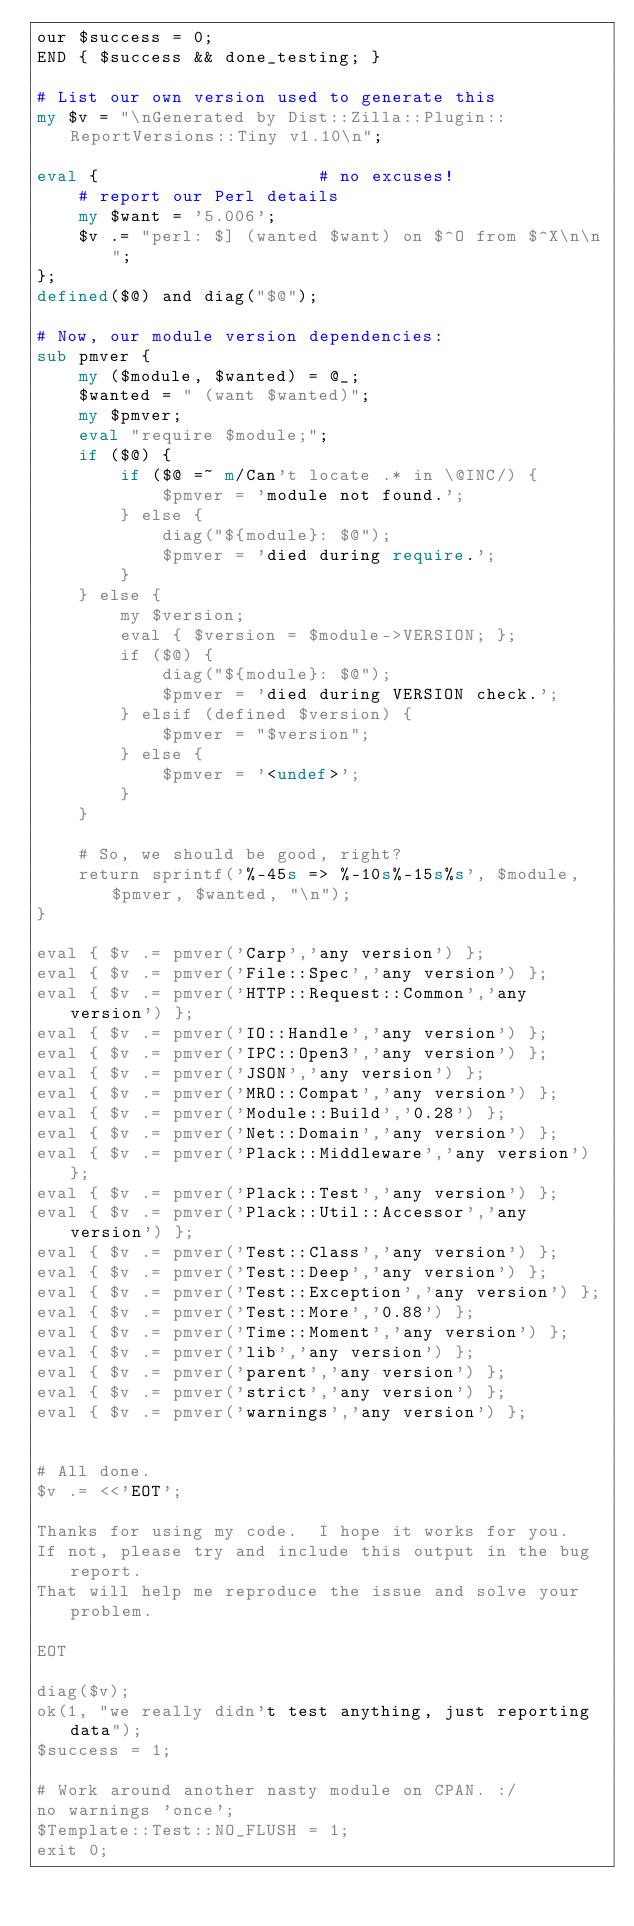Convert code to text. <code><loc_0><loc_0><loc_500><loc_500><_Perl_>our $success = 0;
END { $success && done_testing; }

# List our own version used to generate this
my $v = "\nGenerated by Dist::Zilla::Plugin::ReportVersions::Tiny v1.10\n";

eval {                     # no excuses!
    # report our Perl details
    my $want = '5.006';
    $v .= "perl: $] (wanted $want) on $^O from $^X\n\n";
};
defined($@) and diag("$@");

# Now, our module version dependencies:
sub pmver {
    my ($module, $wanted) = @_;
    $wanted = " (want $wanted)";
    my $pmver;
    eval "require $module;";
    if ($@) {
        if ($@ =~ m/Can't locate .* in \@INC/) {
            $pmver = 'module not found.';
        } else {
            diag("${module}: $@");
            $pmver = 'died during require.';
        }
    } else {
        my $version;
        eval { $version = $module->VERSION; };
        if ($@) {
            diag("${module}: $@");
            $pmver = 'died during VERSION check.';
        } elsif (defined $version) {
            $pmver = "$version";
        } else {
            $pmver = '<undef>';
        }
    }

    # So, we should be good, right?
    return sprintf('%-45s => %-10s%-15s%s', $module, $pmver, $wanted, "\n");
}

eval { $v .= pmver('Carp','any version') };
eval { $v .= pmver('File::Spec','any version') };
eval { $v .= pmver('HTTP::Request::Common','any version') };
eval { $v .= pmver('IO::Handle','any version') };
eval { $v .= pmver('IPC::Open3','any version') };
eval { $v .= pmver('JSON','any version') };
eval { $v .= pmver('MRO::Compat','any version') };
eval { $v .= pmver('Module::Build','0.28') };
eval { $v .= pmver('Net::Domain','any version') };
eval { $v .= pmver('Plack::Middleware','any version') };
eval { $v .= pmver('Plack::Test','any version') };
eval { $v .= pmver('Plack::Util::Accessor','any version') };
eval { $v .= pmver('Test::Class','any version') };
eval { $v .= pmver('Test::Deep','any version') };
eval { $v .= pmver('Test::Exception','any version') };
eval { $v .= pmver('Test::More','0.88') };
eval { $v .= pmver('Time::Moment','any version') };
eval { $v .= pmver('lib','any version') };
eval { $v .= pmver('parent','any version') };
eval { $v .= pmver('strict','any version') };
eval { $v .= pmver('warnings','any version') };


# All done.
$v .= <<'EOT';

Thanks for using my code.  I hope it works for you.
If not, please try and include this output in the bug report.
That will help me reproduce the issue and solve your problem.

EOT

diag($v);
ok(1, "we really didn't test anything, just reporting data");
$success = 1;

# Work around another nasty module on CPAN. :/
no warnings 'once';
$Template::Test::NO_FLUSH = 1;
exit 0;
</code> 